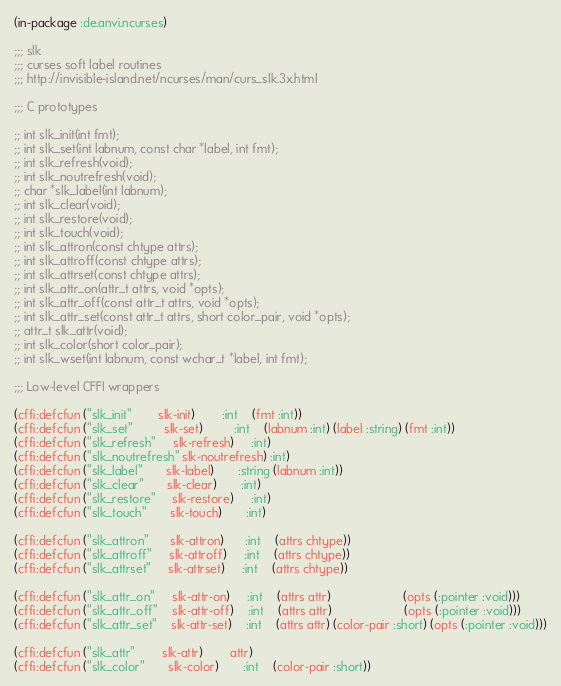<code> <loc_0><loc_0><loc_500><loc_500><_Lisp_>(in-package :de.anvi.ncurses)

;;; slk
;;; curses soft label routines
;;; http://invisible-island.net/ncurses/man/curs_slk.3x.html

;;; C prototypes

;; int slk_init(int fmt);
;; int slk_set(int labnum, const char *label, int fmt);
;; int slk_refresh(void);
;; int slk_noutrefresh(void);
;; char *slk_label(int labnum);
;; int slk_clear(void);
;; int slk_restore(void);
;; int slk_touch(void);
;; int slk_attron(const chtype attrs);
;; int slk_attroff(const chtype attrs);
;; int slk_attrset(const chtype attrs);
;; int slk_attr_on(attr_t attrs, void *opts);
;; int slk_attr_off(const attr_t attrs, void *opts);
;; int slk_attr_set(const attr_t attrs, short color_pair, void *opts);
;; attr_t slk_attr(void);
;; int slk_color(short color_pair);
;; int slk_wset(int labnum, const wchar_t *label, int fmt);

;;; Low-level CFFI wrappers

(cffi:defcfun ("slk_init"        slk-init)        :int    (fmt :int))
(cffi:defcfun ("slk_set"         slk-set)         :int    (labnum :int) (label :string) (fmt :int))
(cffi:defcfun ("slk_refresh"     slk-refresh)     :int)
(cffi:defcfun ("slk_noutrefresh" slk-noutrefresh) :int)
(cffi:defcfun ("slk_label"       slk-label)       :string (labnum :int))
(cffi:defcfun ("slk_clear"       slk-clear)       :int)
(cffi:defcfun ("slk_restore"     slk-restore)     :int)
(cffi:defcfun ("slk_touch"       slk-touch)       :int)

(cffi:defcfun ("slk_attron"      slk-attron)      :int    (attrs chtype))
(cffi:defcfun ("slk_attroff"     slk-attroff)     :int    (attrs chtype))
(cffi:defcfun ("slk_attrset"     slk-attrset)     :int    (attrs chtype))

(cffi:defcfun ("slk_attr_on"     slk-attr-on)     :int    (attrs attr)                     (opts (:pointer :void)))
(cffi:defcfun ("slk_attr_off"    slk-attr-off)    :int    (attrs attr)                     (opts (:pointer :void)))
(cffi:defcfun ("slk_attr_set"    slk-attr-set)    :int    (attrs attr) (color-pair :short) (opts (:pointer :void)))

(cffi:defcfun ("slk_attr"        slk-attr)        attr)
(cffi:defcfun ("slk_color"       slk-color)       :int    (color-pair :short))
</code> 